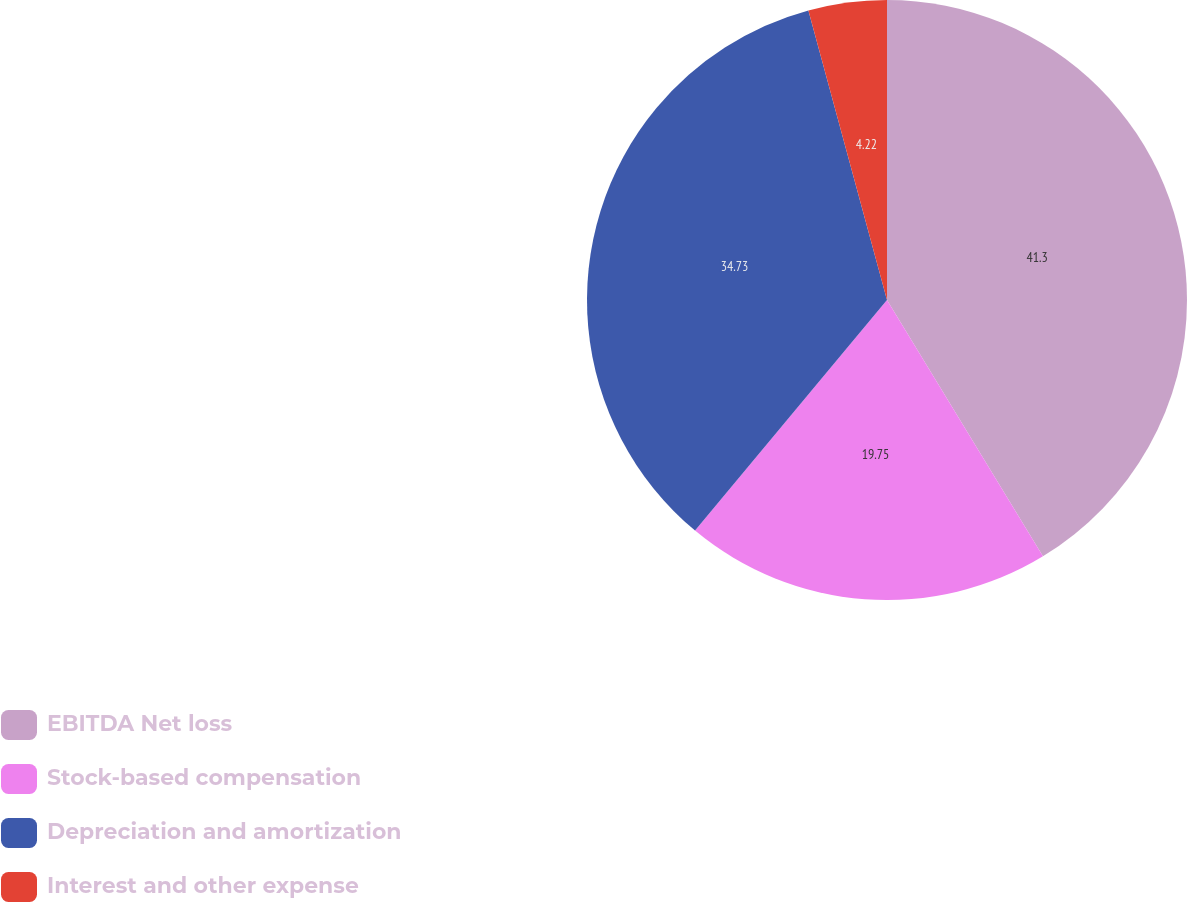Convert chart. <chart><loc_0><loc_0><loc_500><loc_500><pie_chart><fcel>EBITDA Net loss<fcel>Stock-based compensation<fcel>Depreciation and amortization<fcel>Interest and other expense<nl><fcel>41.3%<fcel>19.75%<fcel>34.73%<fcel>4.22%<nl></chart> 